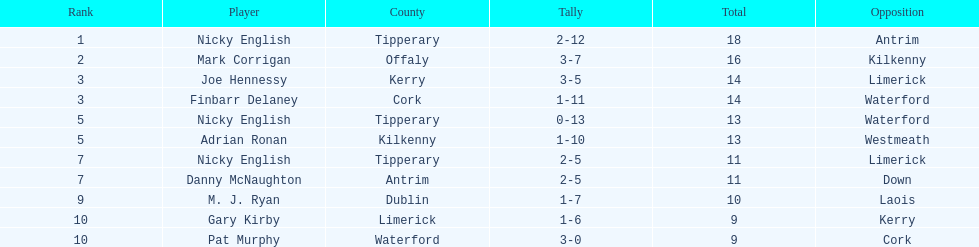If you combined all the total's, what would the amount be? 138. 